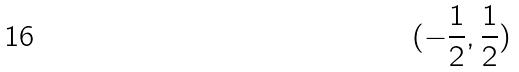Convert formula to latex. <formula><loc_0><loc_0><loc_500><loc_500>( - \frac { 1 } { 2 } , \frac { 1 } { 2 } )</formula> 